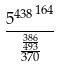Convert formula to latex. <formula><loc_0><loc_0><loc_500><loc_500>\frac { { 5 ^ { 4 3 8 } } ^ { 1 6 4 } } { \frac { \frac { 3 8 6 } { 4 9 3 } } { 3 7 0 } }</formula> 